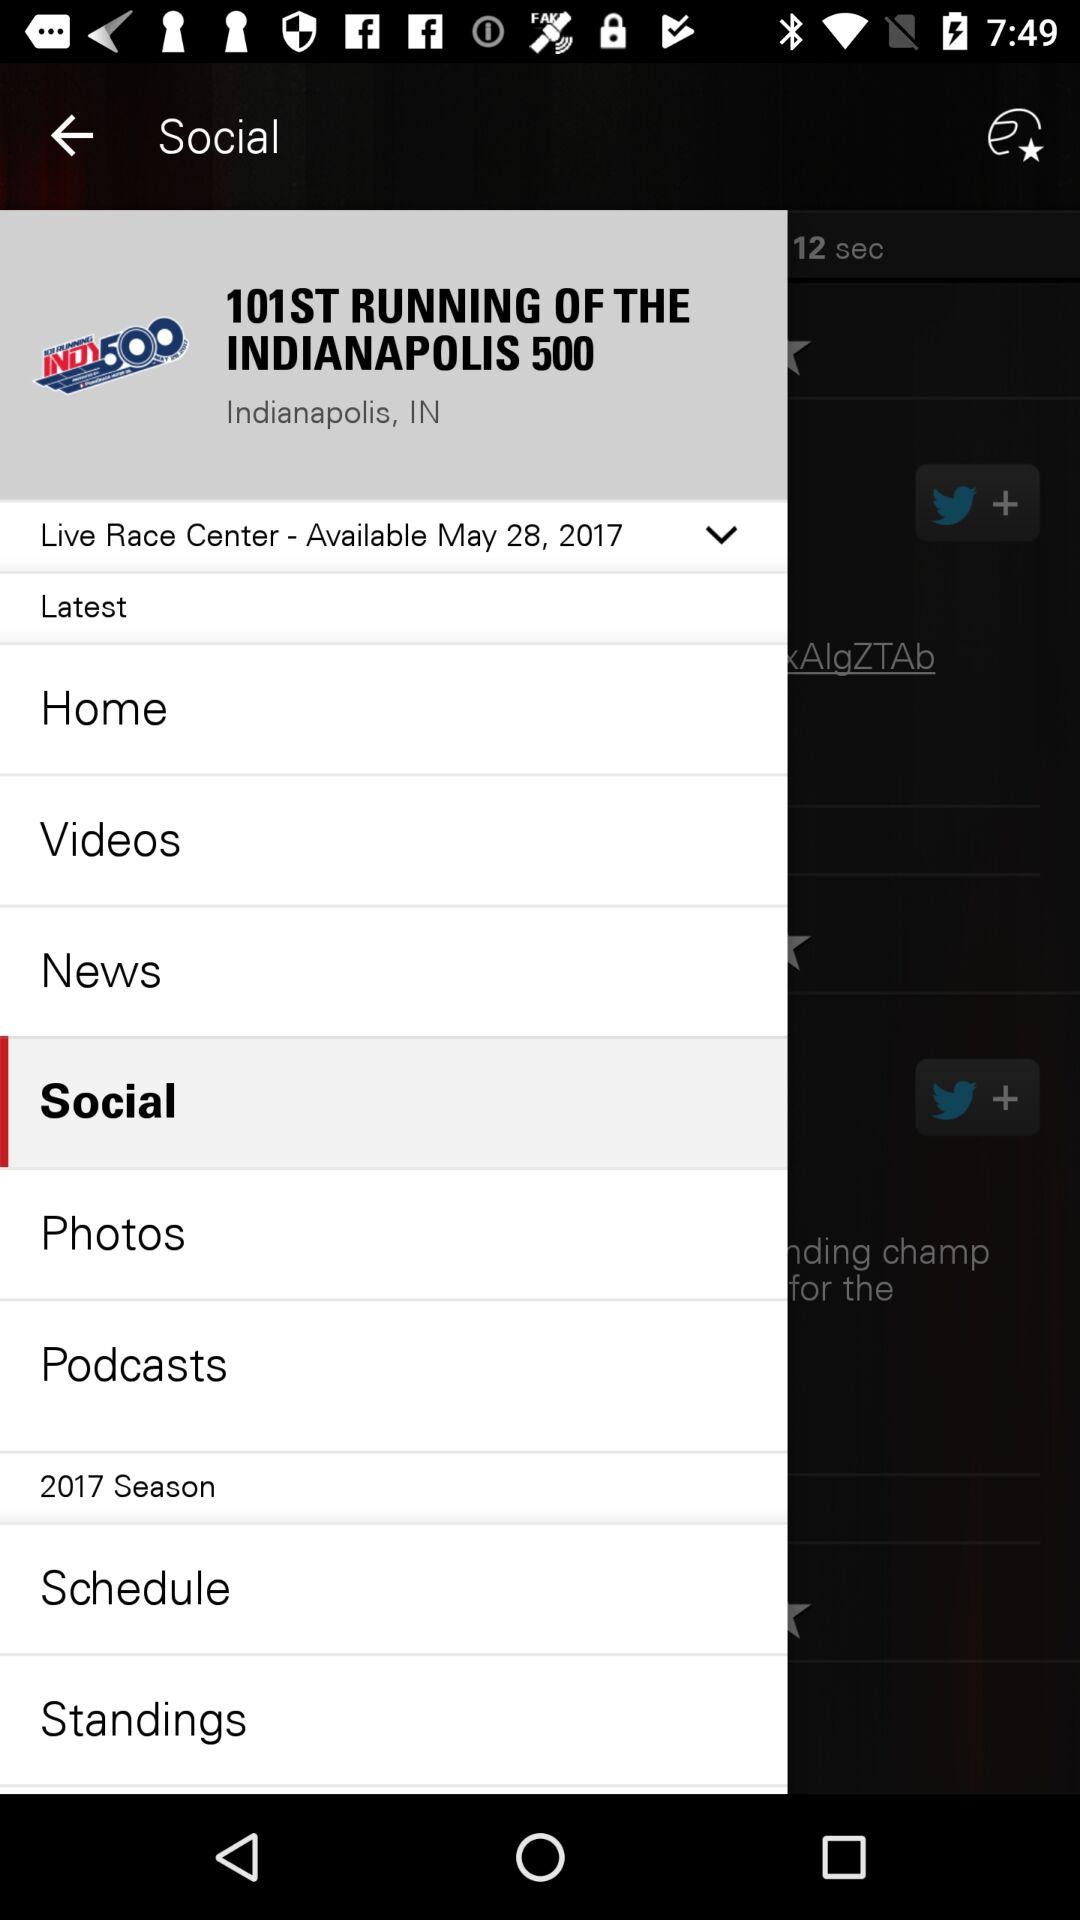Which item is currently selected? The currently selected item is "Social". 